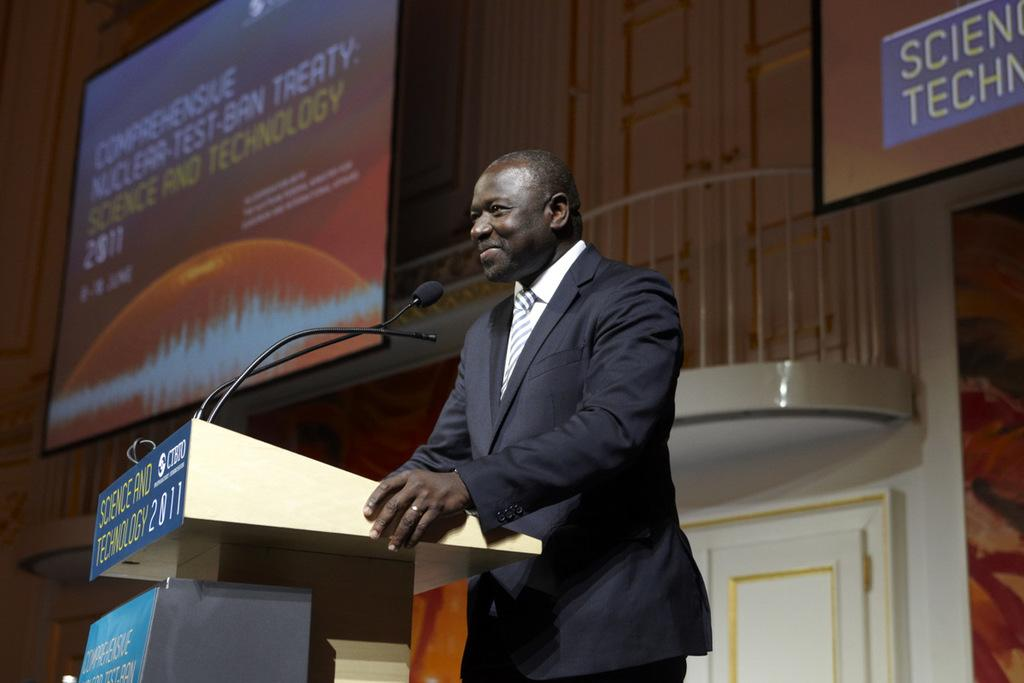What is the person in the image doing? There is a person standing in front of the podium. What is on the podium? There is a mic on the podium, as well as a board with text. What can be seen on the screens in the image? The screens are visible in the image, but their content is not specified. How many chairs are visible in the image? There is no information about chairs in the provided facts, so we cannot determine the number of chairs in the image. 